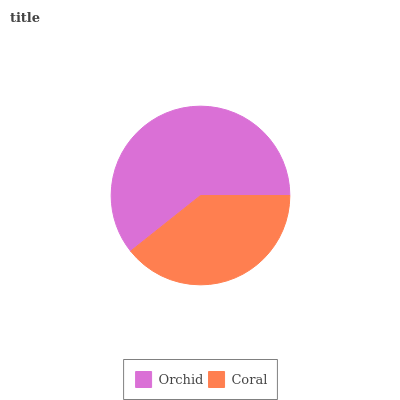Is Coral the minimum?
Answer yes or no. Yes. Is Orchid the maximum?
Answer yes or no. Yes. Is Coral the maximum?
Answer yes or no. No. Is Orchid greater than Coral?
Answer yes or no. Yes. Is Coral less than Orchid?
Answer yes or no. Yes. Is Coral greater than Orchid?
Answer yes or no. No. Is Orchid less than Coral?
Answer yes or no. No. Is Orchid the high median?
Answer yes or no. Yes. Is Coral the low median?
Answer yes or no. Yes. Is Coral the high median?
Answer yes or no. No. Is Orchid the low median?
Answer yes or no. No. 